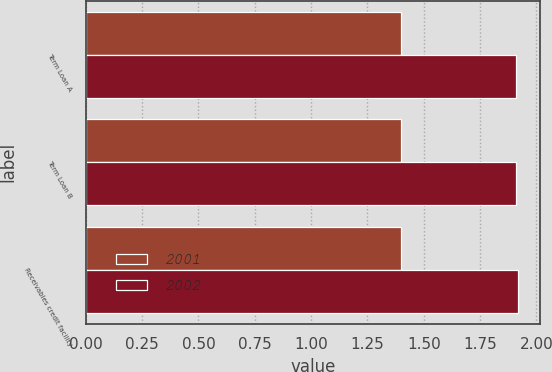<chart> <loc_0><loc_0><loc_500><loc_500><stacked_bar_chart><ecel><fcel>Term Loan A<fcel>Term Loan B<fcel>Receivables credit facility<nl><fcel>2001<fcel>1.4<fcel>1.4<fcel>1.4<nl><fcel>2002<fcel>1.91<fcel>1.91<fcel>1.92<nl></chart> 